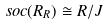Convert formula to latex. <formula><loc_0><loc_0><loc_500><loc_500>s o c ( R _ { R } ) \cong R / J</formula> 